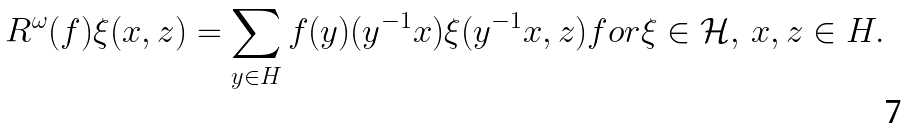Convert formula to latex. <formula><loc_0><loc_0><loc_500><loc_500>R ^ { \omega } ( f ) \xi ( x , z ) = \sum _ { y \in H } f ( y ) ( y ^ { - 1 } x ) \xi ( y ^ { - 1 } x , z ) f o r \xi \in \mathcal { H } , \, x , z \in H .</formula> 